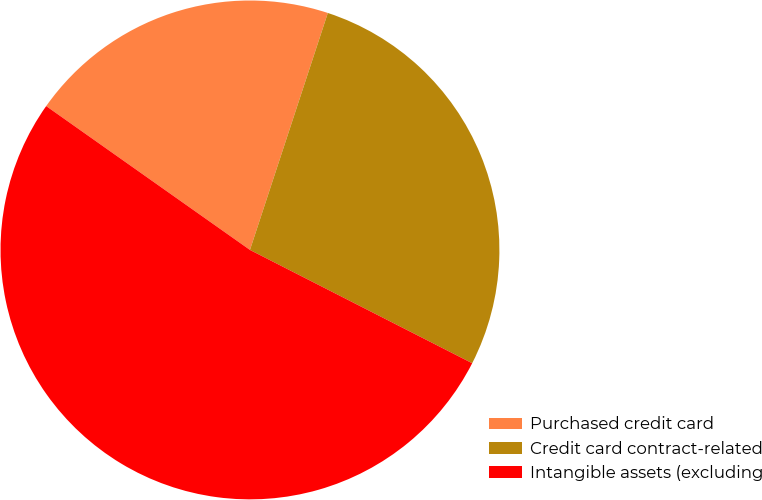<chart> <loc_0><loc_0><loc_500><loc_500><pie_chart><fcel>Purchased credit card<fcel>Credit card contract-related<fcel>Intangible assets (excluding<nl><fcel>20.27%<fcel>27.45%<fcel>52.28%<nl></chart> 